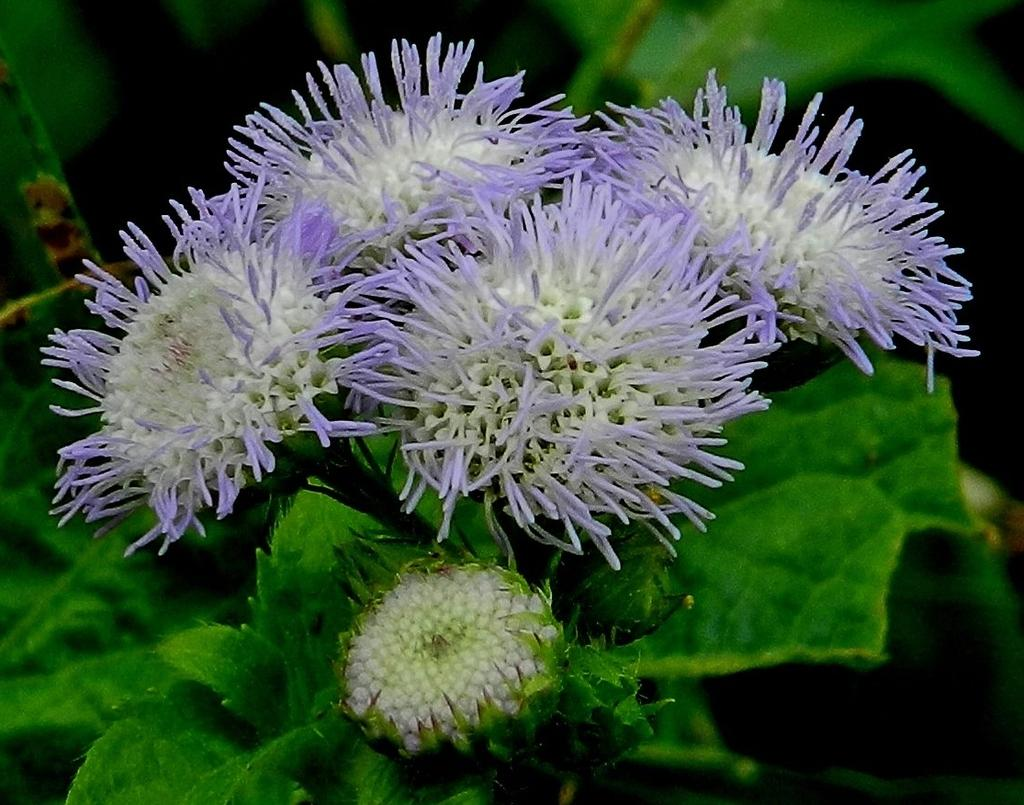What type of plants can be seen in the image? There are flowers in the image. What color are the flowers? The flowers are in violet color. What else is present in the image besides the flowers? There are leaves in the image. What color are the leaves? The leaves are in green color. What type of copper material can be seen in the image? There is no copper material present in the image; it features flowers and leaves. 